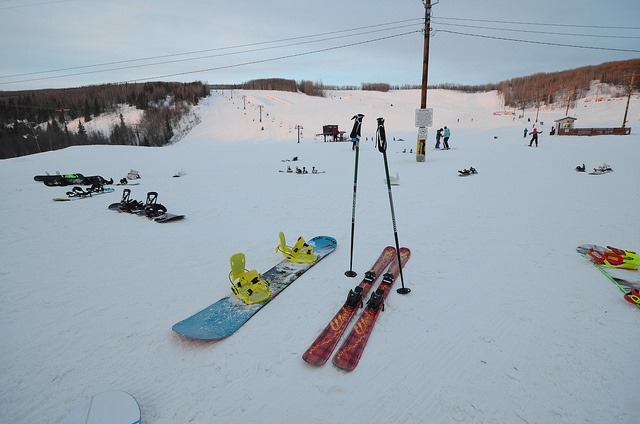Describe the objects in this image and their specific colors. I can see skis in darkgray, maroon, gray, black, and brown tones, snowboard in darkgray, gray, and teal tones, snowboard in darkgray, black, and gray tones, snowboard in darkgray, black, and gray tones, and snowboard in darkgray, black, and gray tones in this image. 